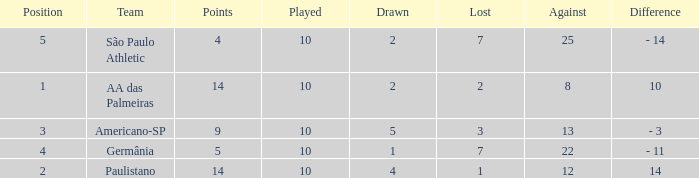What team has an against more than 8, lost of 7, and the position is 5? São Paulo Athletic. 